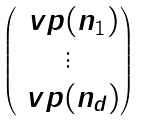Convert formula to latex. <formula><loc_0><loc_0><loc_500><loc_500>\begin{pmatrix} \ v p ( n _ { 1 } ) \\ \vdots \\ \ v p ( n _ { d } ) \end{pmatrix}</formula> 